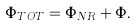<formula> <loc_0><loc_0><loc_500><loc_500>\Phi _ { T O T } = \Phi _ { N R } + \Phi .</formula> 